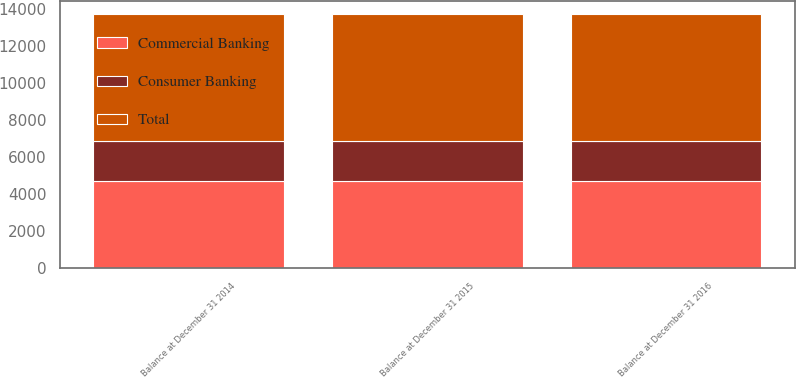<chart> <loc_0><loc_0><loc_500><loc_500><stacked_bar_chart><ecel><fcel>Balance at December 31 2014<fcel>Balance at December 31 2015<fcel>Balance at December 31 2016<nl><fcel>Consumer Banking<fcel>2136<fcel>2136<fcel>2136<nl><fcel>Commercial Banking<fcel>4740<fcel>4740<fcel>4740<nl><fcel>Total<fcel>6876<fcel>6876<fcel>6876<nl></chart> 